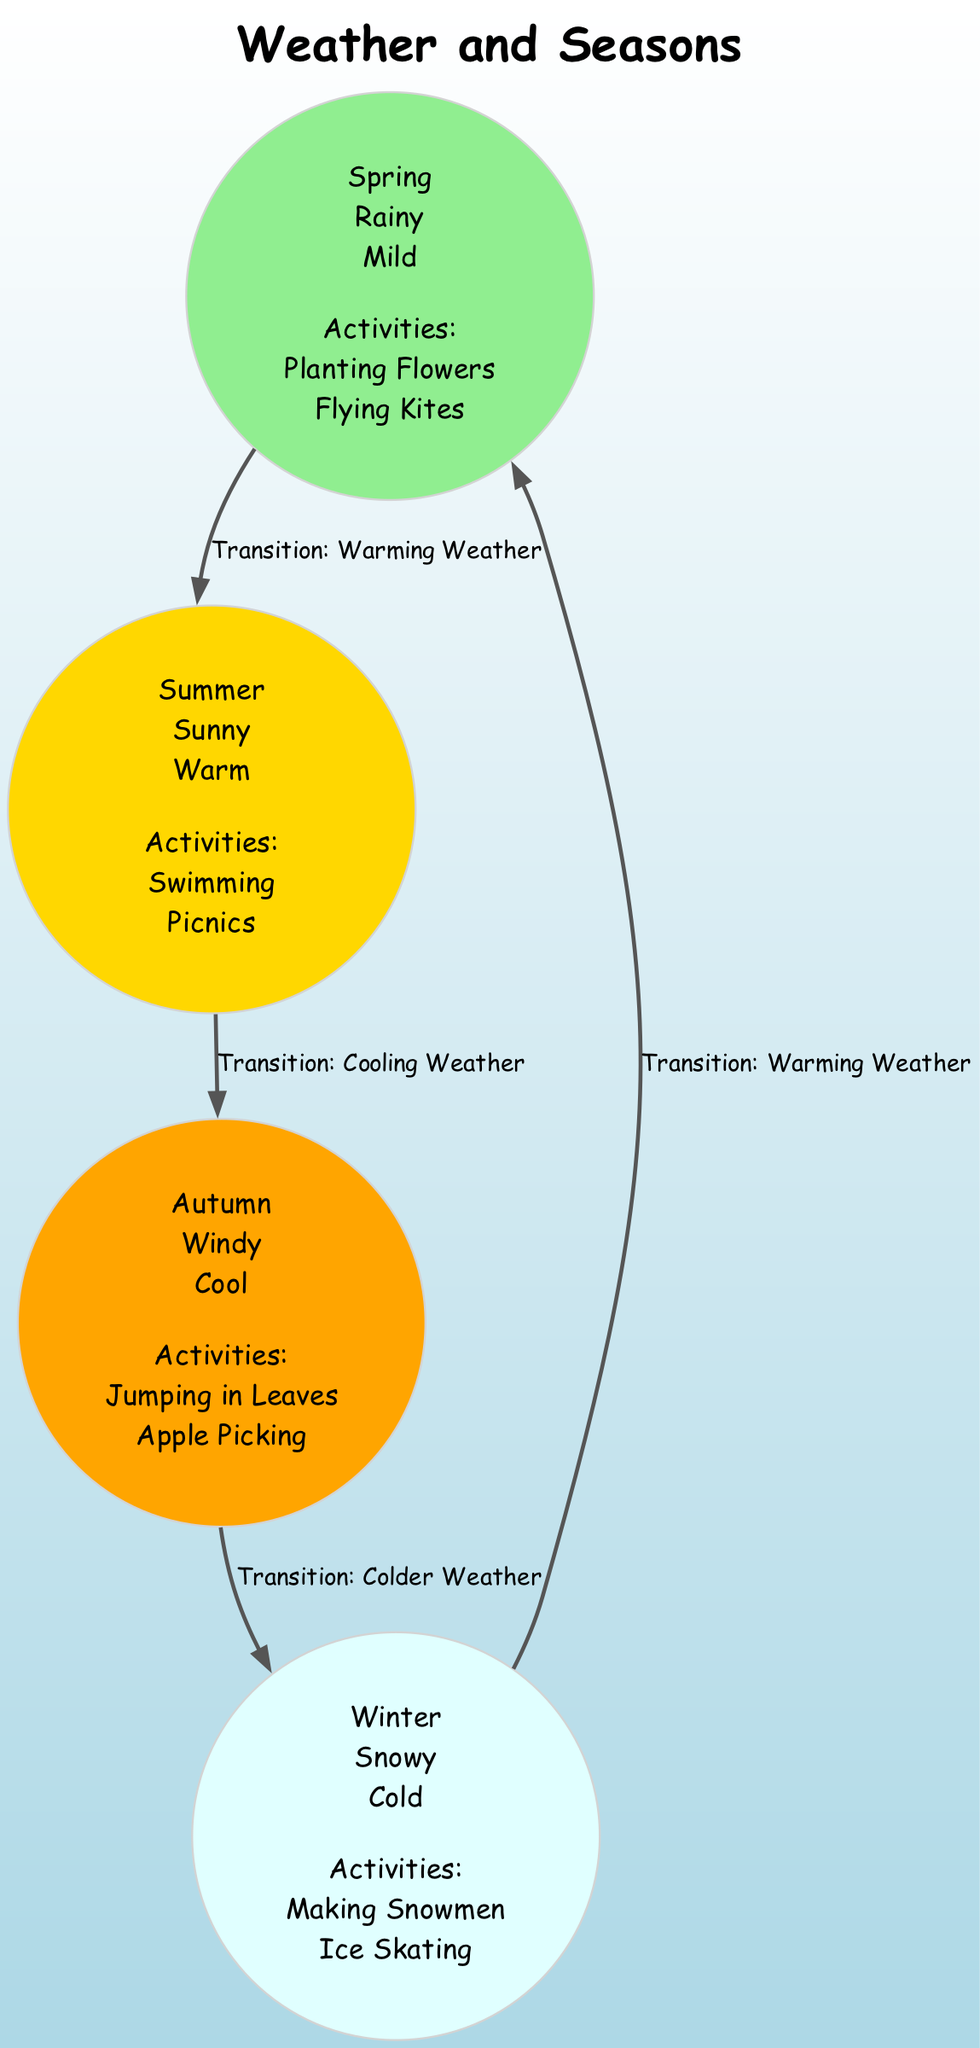What are the activities associated with summer? Looking at the "summer" node in the diagram, it lists the activities below its label. The activities for summer are "Swimming" and "Picnics".
Answer: Swimming, Picnics Which season is characterized by windy weather? By examining the "autumn" node in the diagram, it specifies that the weather during this season is "Windy".
Answer: Autumn How many total seasons are represented in the diagram? The diagram contains four nodes, each representing a distinct season: spring, summer, autumn, and winter. Thus, the total number of seasons is four.
Answer: 4 What is the weather in winter? The "winter" node clearly indicates that the weather during this season is "Snowy".
Answer: Snowy What is the transition from summer to autumn? The edge connection from "summer" to "autumn" is labeled as "Transition: Cooling Weather", indicating this relationship between the two seasons.
Answer: Cooling Weather What activities can children enjoy in spring? The "spring" node lists its activities, which are "Planting Flowers" and "Flying Kites".
Answer: Planting Flowers, Flying Kites Which season is associated with making snowmen? The activities listed under the "winter" node include "Making Snowmen", explicitly linking this activity to the winter season.
Answer: Winter Name the temperature condition during autumn. The "autumn" node states that the temperature during this season is "Cool".
Answer: Cool Which two seasons have a warming weather transition? Reviewing the edges, we see transitions labeled "Transition: Warming Weather" from winter to spring and spring to summer, indicating these two pairs of seasons are associated with warming transitions.
Answer: Winter, Spring What is the color representing spring in the diagram? The "spring" node's fill color is defined by the function as light green, which is indicated in the diagram visualization.
Answer: Light Green 